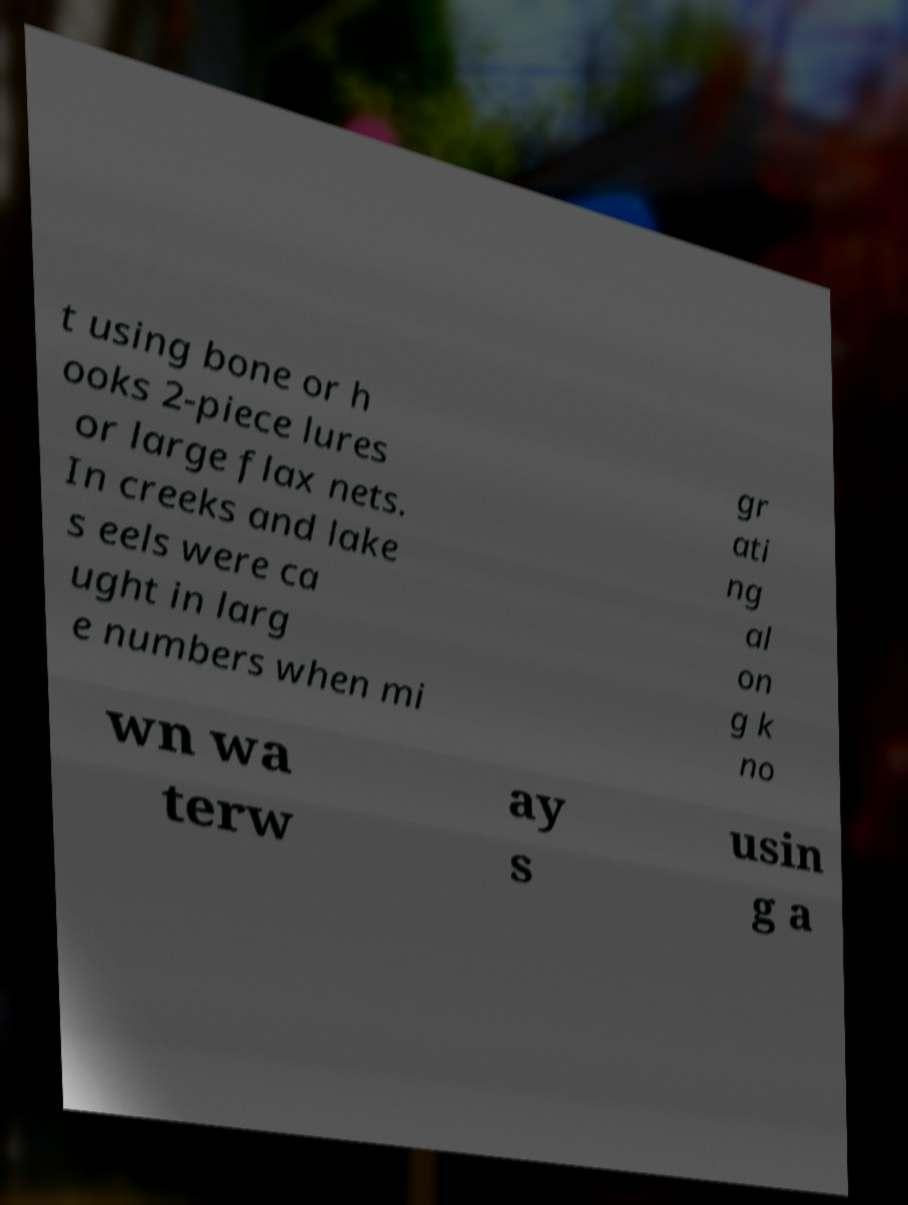Can you accurately transcribe the text from the provided image for me? t using bone or h ooks 2-piece lures or large flax nets. In creeks and lake s eels were ca ught in larg e numbers when mi gr ati ng al on g k no wn wa terw ay s usin g a 